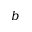<formula> <loc_0><loc_0><loc_500><loc_500>b</formula> 